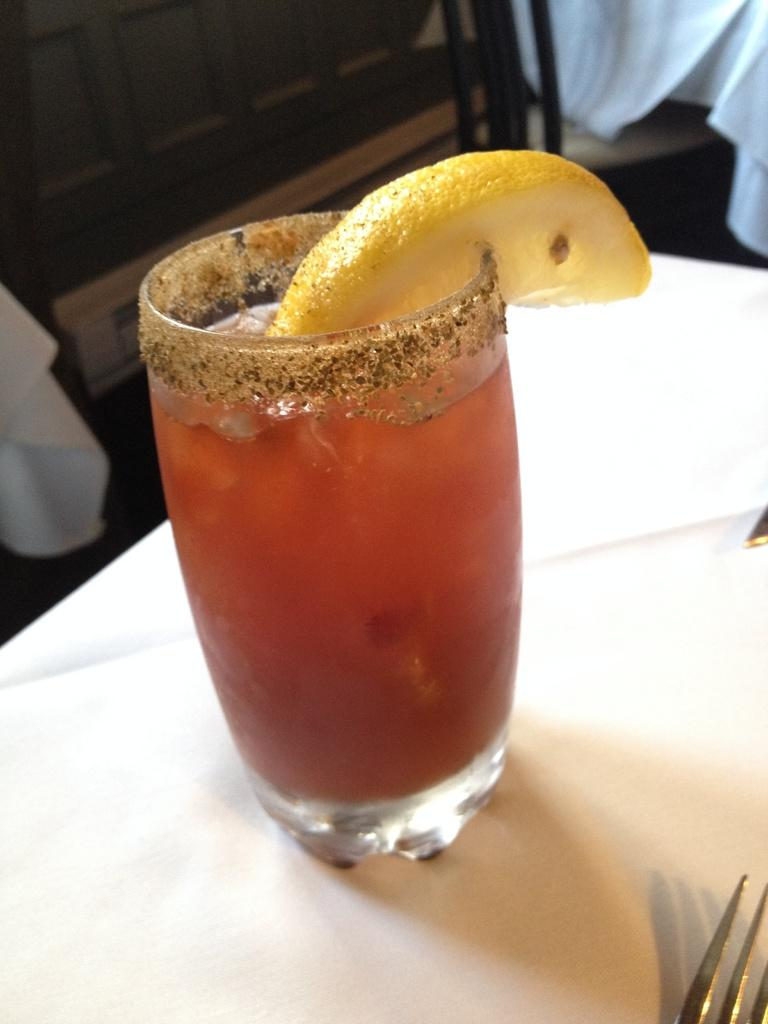What is in the glass that is visible in the image? There is a glass of juice in the image. What is placed on top of the glass of juice? There is a lemon on the glass of juice. What utensil can be seen in the foreground of the image? There is a fork in the foreground of the image. What can be seen in the background of the image? There are objects in the background of the image. What type of faucet is visible in the image? There is no faucet present in the image. 